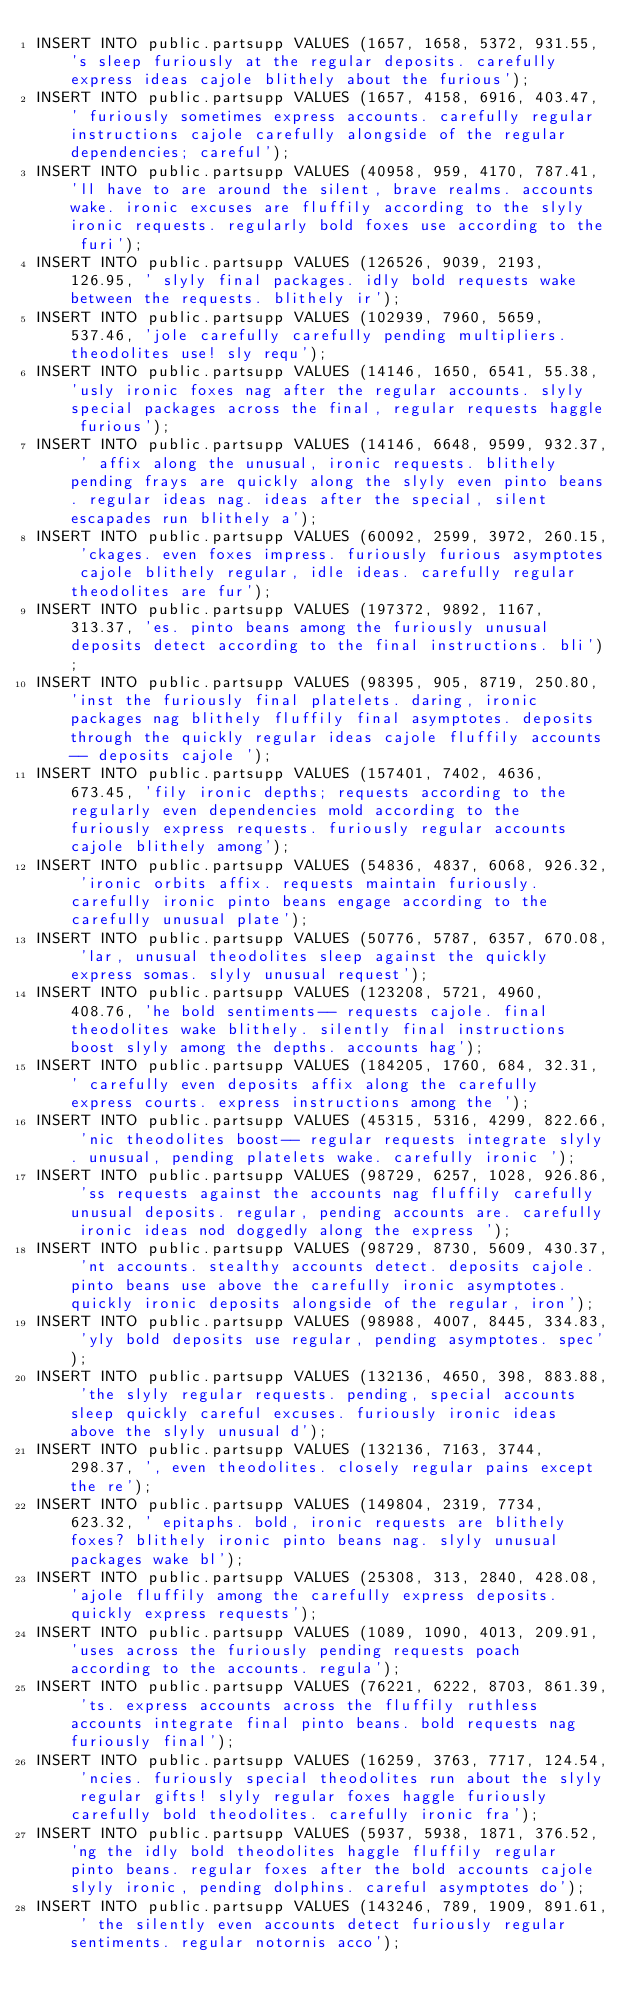<code> <loc_0><loc_0><loc_500><loc_500><_SQL_>INSERT INTO public.partsupp VALUES (1657, 1658, 5372, 931.55, 's sleep furiously at the regular deposits. carefully express ideas cajole blithely about the furious');
INSERT INTO public.partsupp VALUES (1657, 4158, 6916, 403.47, ' furiously sometimes express accounts. carefully regular instructions cajole carefully alongside of the regular dependencies; careful');
INSERT INTO public.partsupp VALUES (40958, 959, 4170, 787.41, 'll have to are around the silent, brave realms. accounts wake. ironic excuses are fluffily according to the slyly ironic requests. regularly bold foxes use according to the furi');
INSERT INTO public.partsupp VALUES (126526, 9039, 2193, 126.95, ' slyly final packages. idly bold requests wake between the requests. blithely ir');
INSERT INTO public.partsupp VALUES (102939, 7960, 5659, 537.46, 'jole carefully carefully pending multipliers. theodolites use! sly requ');
INSERT INTO public.partsupp VALUES (14146, 1650, 6541, 55.38, 'usly ironic foxes nag after the regular accounts. slyly special packages across the final, regular requests haggle furious');
INSERT INTO public.partsupp VALUES (14146, 6648, 9599, 932.37, ' affix along the unusual, ironic requests. blithely pending frays are quickly along the slyly even pinto beans. regular ideas nag. ideas after the special, silent escapades run blithely a');
INSERT INTO public.partsupp VALUES (60092, 2599, 3972, 260.15, 'ckages. even foxes impress. furiously furious asymptotes cajole blithely regular, idle ideas. carefully regular theodolites are fur');
INSERT INTO public.partsupp VALUES (197372, 9892, 1167, 313.37, 'es. pinto beans among the furiously unusual deposits detect according to the final instructions. bli');
INSERT INTO public.partsupp VALUES (98395, 905, 8719, 250.80, 'inst the furiously final platelets. daring, ironic packages nag blithely fluffily final asymptotes. deposits through the quickly regular ideas cajole fluffily accounts-- deposits cajole ');
INSERT INTO public.partsupp VALUES (157401, 7402, 4636, 673.45, 'fily ironic depths; requests according to the regularly even dependencies mold according to the furiously express requests. furiously regular accounts cajole blithely among');
INSERT INTO public.partsupp VALUES (54836, 4837, 6068, 926.32, 'ironic orbits affix. requests maintain furiously. carefully ironic pinto beans engage according to the carefully unusual plate');
INSERT INTO public.partsupp VALUES (50776, 5787, 6357, 670.08, 'lar, unusual theodolites sleep against the quickly express somas. slyly unusual request');
INSERT INTO public.partsupp VALUES (123208, 5721, 4960, 408.76, 'he bold sentiments-- requests cajole. final theodolites wake blithely. silently final instructions boost slyly among the depths. accounts hag');
INSERT INTO public.partsupp VALUES (184205, 1760, 684, 32.31, ' carefully even deposits affix along the carefully express courts. express instructions among the ');
INSERT INTO public.partsupp VALUES (45315, 5316, 4299, 822.66, 'nic theodolites boost-- regular requests integrate slyly. unusual, pending platelets wake. carefully ironic ');
INSERT INTO public.partsupp VALUES (98729, 6257, 1028, 926.86, 'ss requests against the accounts nag fluffily carefully unusual deposits. regular, pending accounts are. carefully ironic ideas nod doggedly along the express ');
INSERT INTO public.partsupp VALUES (98729, 8730, 5609, 430.37, 'nt accounts. stealthy accounts detect. deposits cajole. pinto beans use above the carefully ironic asymptotes. quickly ironic deposits alongside of the regular, iron');
INSERT INTO public.partsupp VALUES (98988, 4007, 8445, 334.83, 'yly bold deposits use regular, pending asymptotes. spec');
INSERT INTO public.partsupp VALUES (132136, 4650, 398, 883.88, 'the slyly regular requests. pending, special accounts sleep quickly careful excuses. furiously ironic ideas above the slyly unusual d');
INSERT INTO public.partsupp VALUES (132136, 7163, 3744, 298.37, ', even theodolites. closely regular pains except the re');
INSERT INTO public.partsupp VALUES (149804, 2319, 7734, 623.32, ' epitaphs. bold, ironic requests are blithely foxes? blithely ironic pinto beans nag. slyly unusual packages wake bl');
INSERT INTO public.partsupp VALUES (25308, 313, 2840, 428.08, 'ajole fluffily among the carefully express deposits. quickly express requests');
INSERT INTO public.partsupp VALUES (1089, 1090, 4013, 209.91, 'uses across the furiously pending requests poach according to the accounts. regula');
INSERT INTO public.partsupp VALUES (76221, 6222, 8703, 861.39, 'ts. express accounts across the fluffily ruthless accounts integrate final pinto beans. bold requests nag furiously final');
INSERT INTO public.partsupp VALUES (16259, 3763, 7717, 124.54, 'ncies. furiously special theodolites run about the slyly regular gifts! slyly regular foxes haggle furiously carefully bold theodolites. carefully ironic fra');
INSERT INTO public.partsupp VALUES (5937, 5938, 1871, 376.52, 'ng the idly bold theodolites haggle fluffily regular pinto beans. regular foxes after the bold accounts cajole slyly ironic, pending dolphins. careful asymptotes do');
INSERT INTO public.partsupp VALUES (143246, 789, 1909, 891.61, ' the silently even accounts detect furiously regular sentiments. regular notornis acco');</code> 